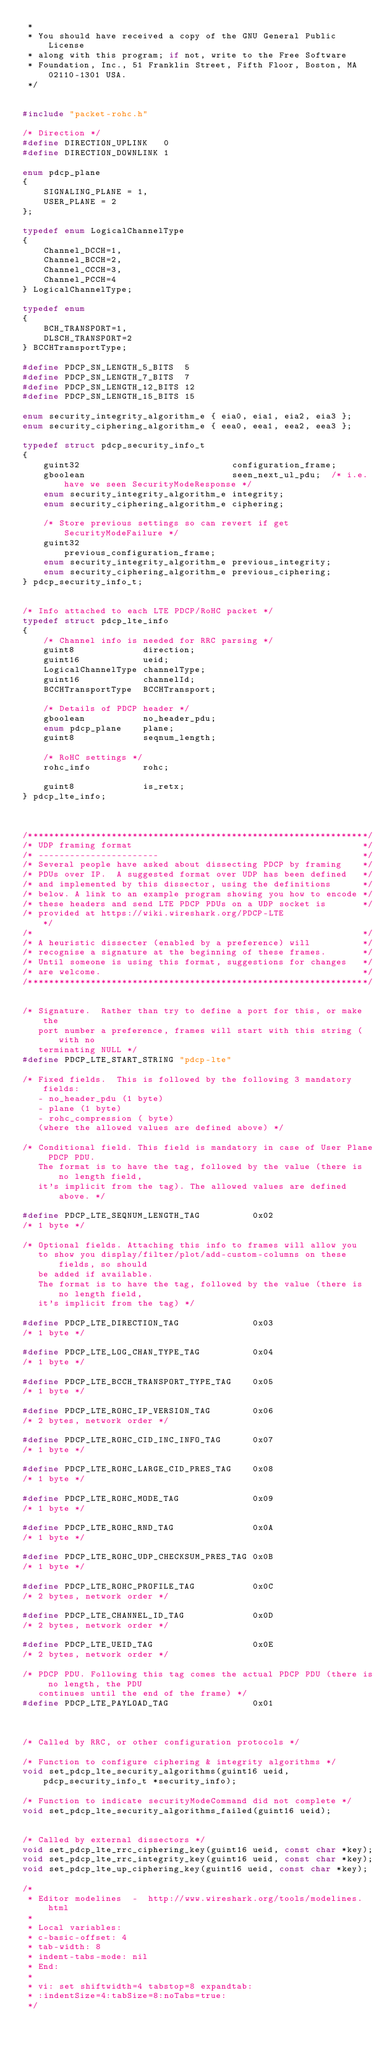<code> <loc_0><loc_0><loc_500><loc_500><_C_> *
 * You should have received a copy of the GNU General Public License
 * along with this program; if not, write to the Free Software
 * Foundation, Inc., 51 Franklin Street, Fifth Floor, Boston, MA 02110-1301 USA.
 */


#include "packet-rohc.h"

/* Direction */
#define DIRECTION_UPLINK   0
#define DIRECTION_DOWNLINK 1

enum pdcp_plane
{
    SIGNALING_PLANE = 1,
    USER_PLANE = 2
};

typedef enum LogicalChannelType
{
    Channel_DCCH=1,
    Channel_BCCH=2,
    Channel_CCCH=3,
    Channel_PCCH=4
} LogicalChannelType;

typedef enum
{
    BCH_TRANSPORT=1,
    DLSCH_TRANSPORT=2
} BCCHTransportType;

#define PDCP_SN_LENGTH_5_BITS  5
#define PDCP_SN_LENGTH_7_BITS  7
#define PDCP_SN_LENGTH_12_BITS 12
#define PDCP_SN_LENGTH_15_BITS 15

enum security_integrity_algorithm_e { eia0, eia1, eia2, eia3 };
enum security_ciphering_algorithm_e { eea0, eea1, eea2, eea3 };

typedef struct pdcp_security_info_t
{
    guint32                             configuration_frame;
    gboolean                            seen_next_ul_pdu;  /* i.e. have we seen SecurityModeResponse */
    enum security_integrity_algorithm_e integrity;
    enum security_ciphering_algorithm_e ciphering;

    /* Store previous settings so can revert if get SecurityModeFailure */
    guint32                             previous_configuration_frame;
    enum security_integrity_algorithm_e previous_integrity;
    enum security_ciphering_algorithm_e previous_ciphering;
} pdcp_security_info_t;


/* Info attached to each LTE PDCP/RoHC packet */
typedef struct pdcp_lte_info
{
    /* Channel info is needed for RRC parsing */
    guint8             direction;
    guint16            ueid;
    LogicalChannelType channelType;
    guint16            channelId;
    BCCHTransportType  BCCHTransport;

    /* Details of PDCP header */
    gboolean           no_header_pdu;
    enum pdcp_plane    plane;
    guint8             seqnum_length;

    /* RoHC settings */
    rohc_info          rohc;

    guint8             is_retx;
} pdcp_lte_info;



/*****************************************************************/
/* UDP framing format                                            */
/* -----------------------                                       */
/* Several people have asked about dissecting PDCP by framing    */
/* PDUs over IP.  A suggested format over UDP has been defined   */
/* and implemented by this dissector, using the definitions      */
/* below. A link to an example program showing you how to encode */
/* these headers and send LTE PDCP PDUs on a UDP socket is       */
/* provided at https://wiki.wireshark.org/PDCP-LTE                */
/*                                                               */
/* A heuristic dissecter (enabled by a preference) will          */
/* recognise a signature at the beginning of these frames.       */
/* Until someone is using this format, suggestions for changes   */
/* are welcome.                                                  */
/*****************************************************************/


/* Signature.  Rather than try to define a port for this, or make the
   port number a preference, frames will start with this string (with no
   terminating NULL */
#define PDCP_LTE_START_STRING "pdcp-lte"

/* Fixed fields.  This is followed by the following 3 mandatory fields:
   - no_header_pdu (1 byte)
   - plane (1 byte)
   - rohc_compression ( byte)
   (where the allowed values are defined above) */

/* Conditional field. This field is mandatory in case of User Plane PDCP PDU.
   The format is to have the tag, followed by the value (there is no length field,
   it's implicit from the tag). The allowed values are defined above. */

#define PDCP_LTE_SEQNUM_LENGTH_TAG          0x02
/* 1 byte */

/* Optional fields. Attaching this info to frames will allow you
   to show you display/filter/plot/add-custom-columns on these fields, so should
   be added if available.
   The format is to have the tag, followed by the value (there is no length field,
   it's implicit from the tag) */

#define PDCP_LTE_DIRECTION_TAG              0x03
/* 1 byte */

#define PDCP_LTE_LOG_CHAN_TYPE_TAG          0x04
/* 1 byte */

#define PDCP_LTE_BCCH_TRANSPORT_TYPE_TAG    0x05
/* 1 byte */

#define PDCP_LTE_ROHC_IP_VERSION_TAG        0x06
/* 2 bytes, network order */

#define PDCP_LTE_ROHC_CID_INC_INFO_TAG      0x07
/* 1 byte */

#define PDCP_LTE_ROHC_LARGE_CID_PRES_TAG    0x08
/* 1 byte */

#define PDCP_LTE_ROHC_MODE_TAG              0x09
/* 1 byte */

#define PDCP_LTE_ROHC_RND_TAG               0x0A
/* 1 byte */

#define PDCP_LTE_ROHC_UDP_CHECKSUM_PRES_TAG 0x0B
/* 1 byte */

#define PDCP_LTE_ROHC_PROFILE_TAG           0x0C
/* 2 bytes, network order */

#define PDCP_LTE_CHANNEL_ID_TAG             0x0D
/* 2 bytes, network order */

#define PDCP_LTE_UEID_TAG                   0x0E
/* 2 bytes, network order */

/* PDCP PDU. Following this tag comes the actual PDCP PDU (there is no length, the PDU
   continues until the end of the frame) */
#define PDCP_LTE_PAYLOAD_TAG                0x01



/* Called by RRC, or other configuration protocols */

/* Function to configure ciphering & integrity algorithms */
void set_pdcp_lte_security_algorithms(guint16 ueid, pdcp_security_info_t *security_info);

/* Function to indicate securityModeCommand did not complete */
void set_pdcp_lte_security_algorithms_failed(guint16 ueid);


/* Called by external dissectors */
void set_pdcp_lte_rrc_ciphering_key(guint16 ueid, const char *key);
void set_pdcp_lte_rrc_integrity_key(guint16 ueid, const char *key);
void set_pdcp_lte_up_ciphering_key(guint16 ueid, const char *key);

/*
 * Editor modelines  -  http://www.wireshark.org/tools/modelines.html
 *
 * Local variables:
 * c-basic-offset: 4
 * tab-width: 8
 * indent-tabs-mode: nil
 * End:
 *
 * vi: set shiftwidth=4 tabstop=8 expandtab:
 * :indentSize=4:tabSize=8:noTabs=true:
 */
</code> 